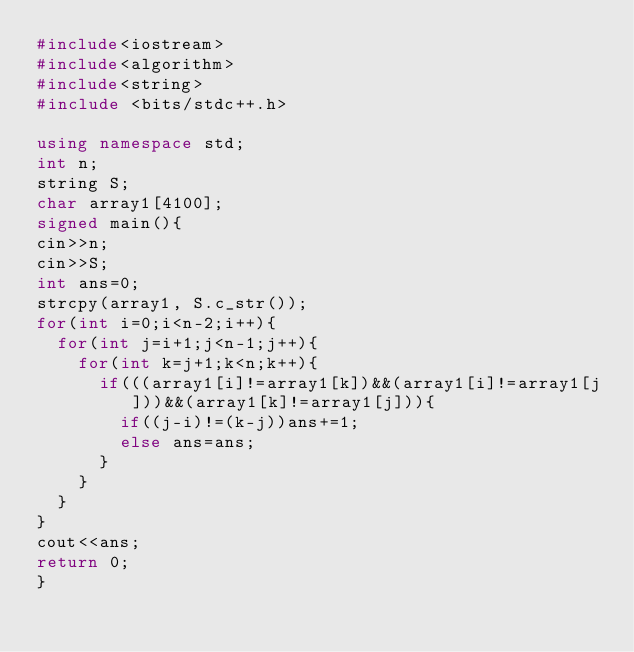Convert code to text. <code><loc_0><loc_0><loc_500><loc_500><_C++_>#include<iostream>
#include<algorithm>
#include<string> 
#include <bits/stdc++.h> 
 
using namespace std;
int n;
string S;
char array1[4100];
signed main(){
cin>>n;
cin>>S;
int ans=0;
strcpy(array1, S.c_str());
for(int i=0;i<n-2;i++){
	for(int j=i+1;j<n-1;j++){
		for(int k=j+1;k<n;k++){
			if(((array1[i]!=array1[k])&&(array1[i]!=array1[j]))&&(array1[k]!=array1[j])){
				if((j-i)!=(k-j))ans+=1;
				else ans=ans;
			}
		}
	}
}
cout<<ans;
return 0;
} </code> 